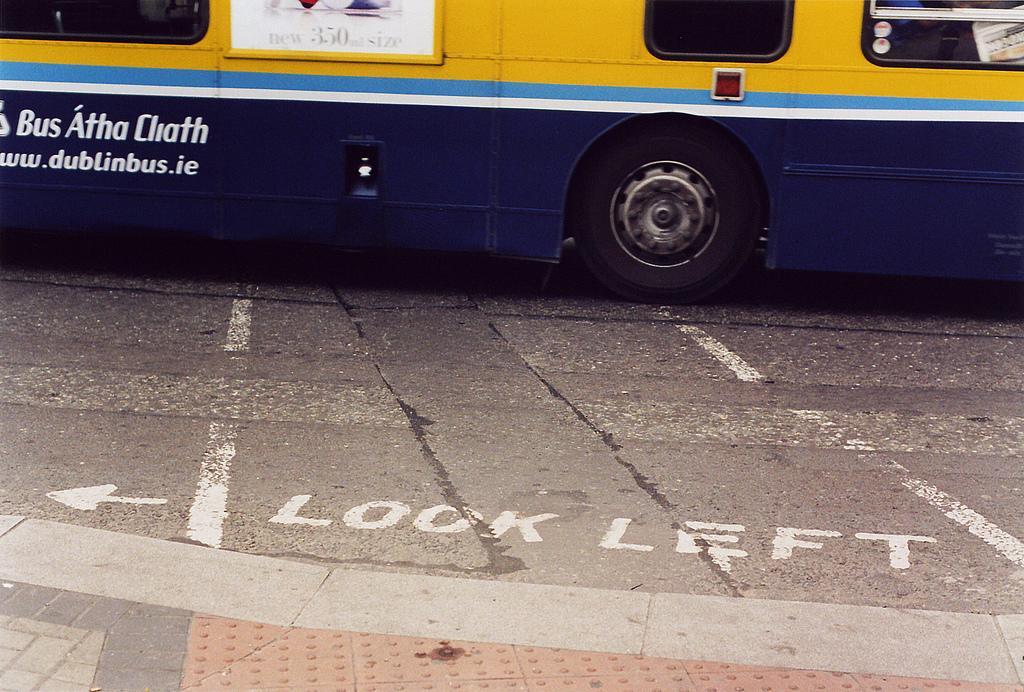Please provide a concise description of this image. In the foreground I can see the road and there is a text on the road. In the background, I can see a bus on the road. I can see the glass windows at the top of the picture. 